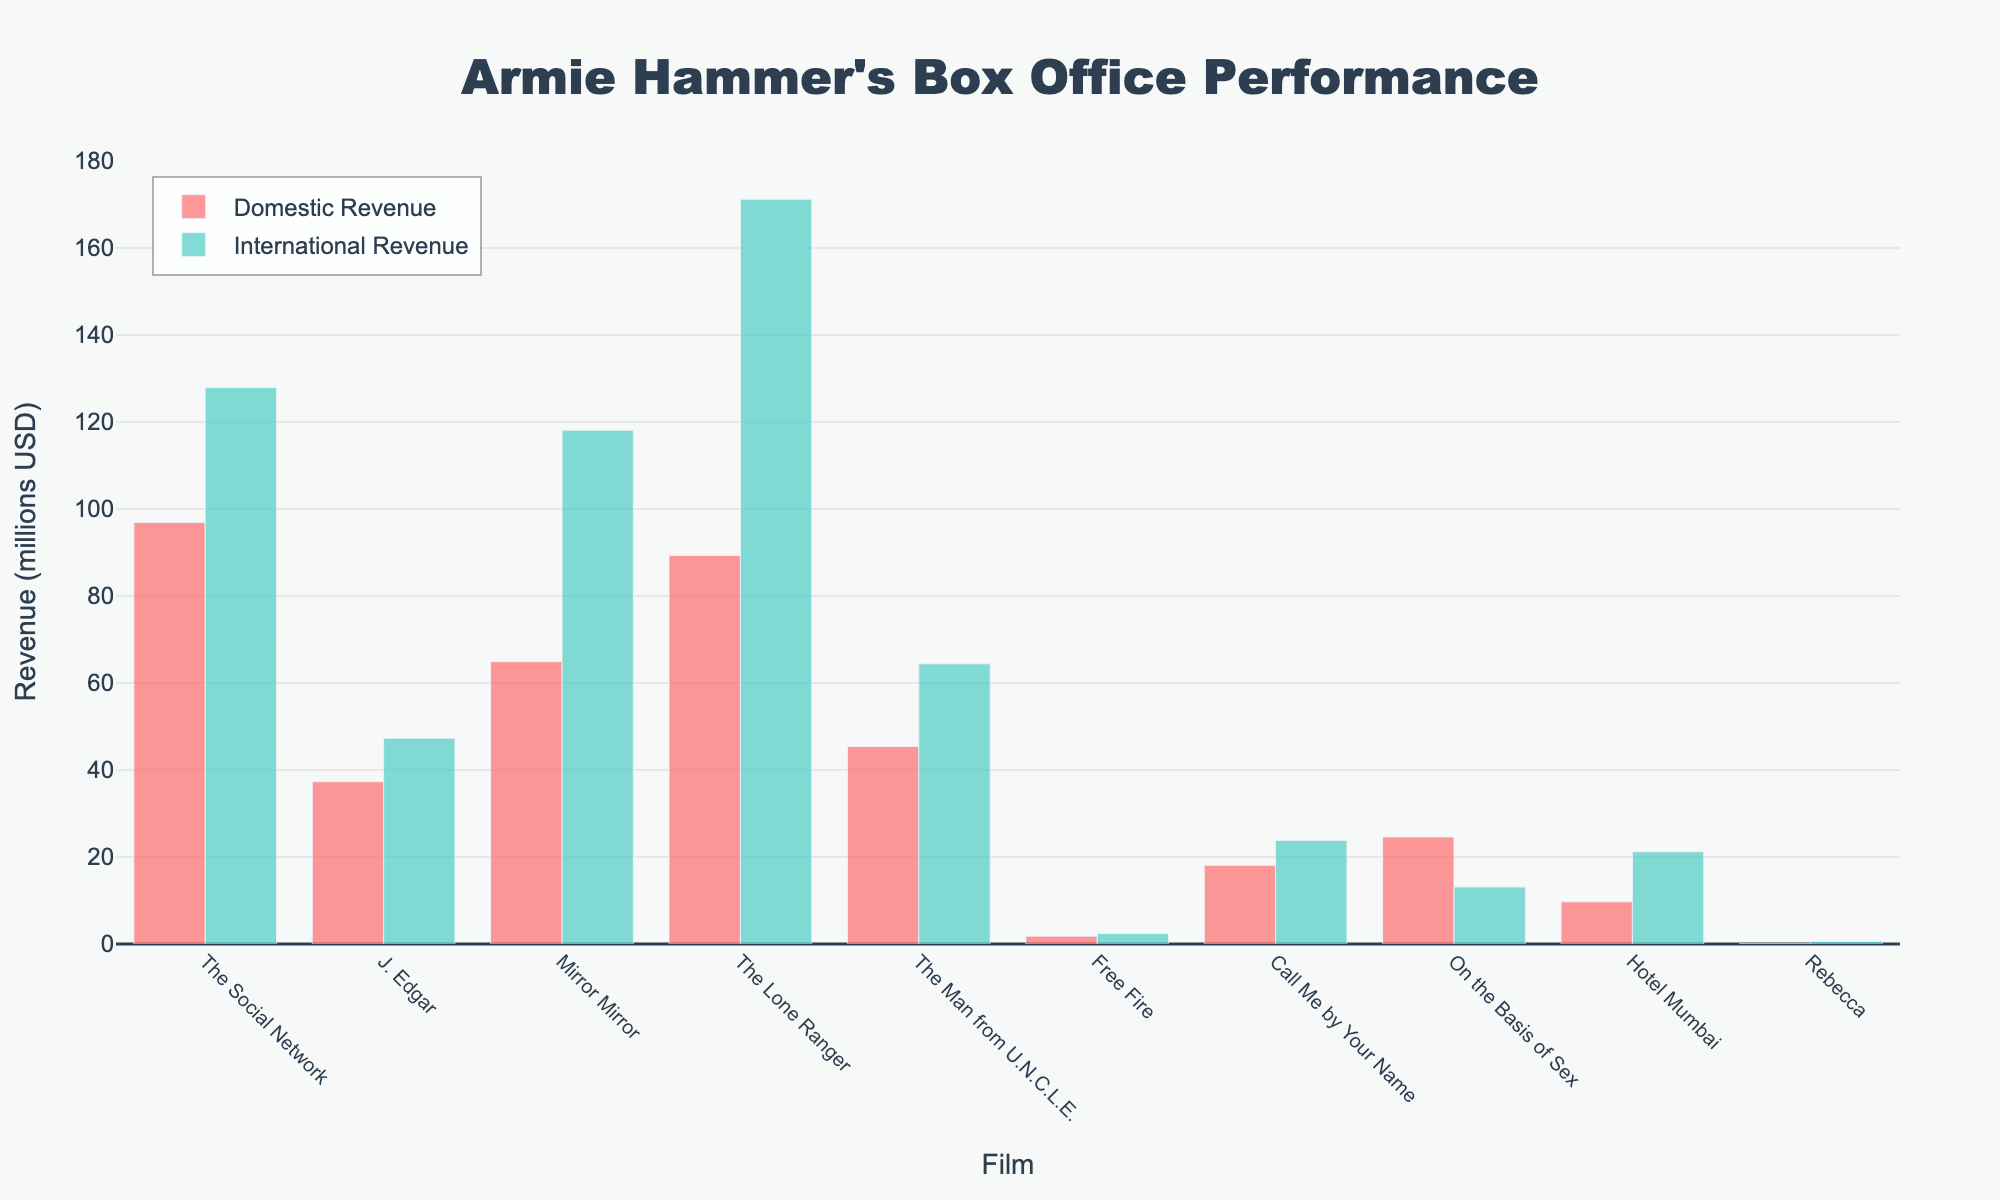What is the title of the plot? The title is displayed at the top of the plot. It says "Armie Hammer's Box Office Performance".
Answer: Armie Hammer's Box Office Performance Which film has the highest domestic revenue? By examining the height of the bars representing domestic revenue, "The Social Network" has the highest bar, indicating the highest domestic revenue.
Answer: The Social Network How much more did "The Lone Ranger" earn internationally compared to domestically? The domestic revenue for "The Lone Ranger" is 89.3 million, and the international revenue is 171.2 million. The difference is 171.2 - 89.3 = 81.9 million.
Answer: 81.9 million Which film has a significantly higher international revenue compared to domestic revenue? By comparing the heights of the bars for domestic and international revenue, "Mirror Mirror" and "The Lone Ranger" show a significant difference, with the international revenue bar being much higher.
Answer: Mirror Mirror and The Lone Ranger What is the average domestic revenue of the films shown? Sum the domestic revenues (96.9 + 37.3 + 64.9 + 89.3 + 45.4 + 1.8 + 18.1 + 24.6 + 9.7 + 0.1) = 388.1 million. Divide by the number of films, which is 10, to get 388.1 / 10 = 38.81 million.
Answer: 38.81 million Which film has the smallest gap between domestic and international revenue? By comparing the heights of the bars representing domestic and international revenues, "On the Basis of Sex" has the smallest gap.
Answer: On the Basis of Sex Is there any film where the domestic revenue exceeds the international revenue? If yes, which one(s)? Comparing the heights of the bars for each film, "On the Basis of Sex" is the only film where the domestic revenue bar is higher than the international revenue bar.
Answer: On the Basis of Sex What is the total revenue (domestic + international) for "Hotel Mumbai"? The domestic revenue for "Hotel Mumbai" is 9.7 million, and the international revenue is 21.2 million. The total is 9.7 + 21.2 = 30.9 million.
Answer: 30.9 million How does the international revenue of "The Man from U.N.C.L.E." compare with that of "Free Fire"? The international revenue for "The Man from U.N.C.L.E." is 64.4 million, whereas for "Free Fire" it is 2.4 million. "The Man from U.N.C.L.E." has a much higher international revenue.
Answer: The Man from U.N.C.L.E. has higher international revenue Which film earned the least in domestic revenue and how much did it earn? By looking at the heights of the bars for domestic revenue, "Rebecca" has the smallest bar, indicating it earned the least in domestic revenue, which is 0.1 million.
Answer: Rebecca, 0.1 million 